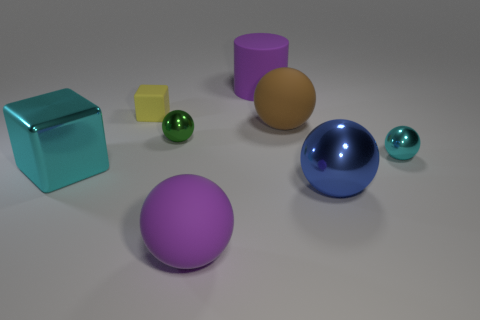Are there fewer yellow things that are behind the cyan metallic ball than brown matte objects?
Your response must be concise. No. Does the big blue metal thing have the same shape as the tiny cyan thing?
Make the answer very short. Yes. What size is the brown rubber sphere that is in front of the purple matte thing that is behind the cube that is right of the cyan block?
Offer a terse response. Large. What material is the cyan object that is the same shape as the yellow object?
Provide a succinct answer. Metal. Is there anything else that has the same size as the blue metal ball?
Offer a very short reply. Yes. How big is the purple object that is in front of the block on the right side of the shiny block?
Give a very brief answer. Large. The large cube has what color?
Offer a very short reply. Cyan. How many metallic objects are left of the large rubber sphere behind the green shiny object?
Ensure brevity in your answer.  2. Is there a cyan thing in front of the cyan object that is to the right of the yellow block?
Offer a very short reply. Yes. There is a big brown rubber ball; are there any large purple matte cylinders right of it?
Your response must be concise. No. 